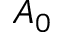<formula> <loc_0><loc_0><loc_500><loc_500>A _ { 0 }</formula> 